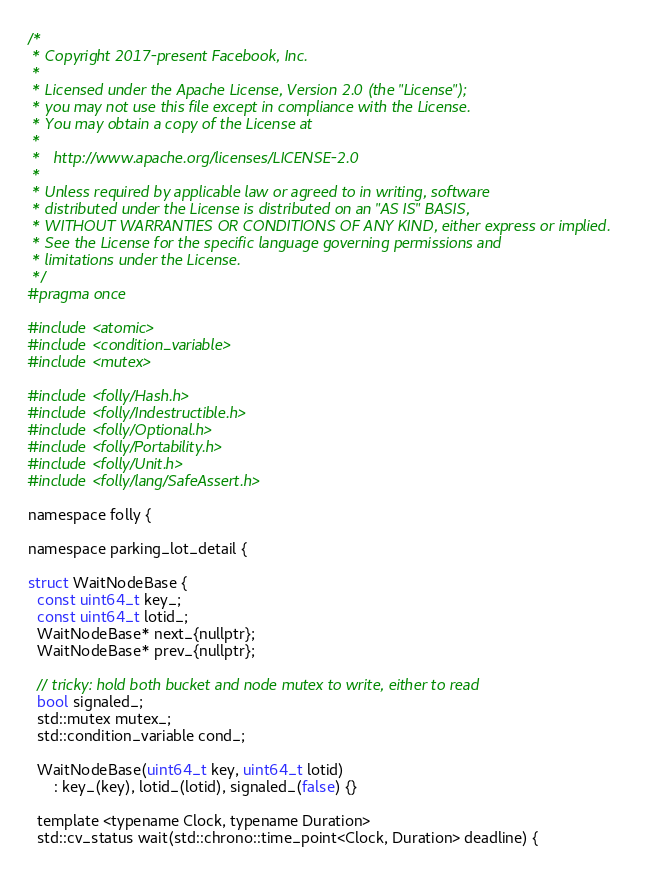<code> <loc_0><loc_0><loc_500><loc_500><_C_>/*
 * Copyright 2017-present Facebook, Inc.
 *
 * Licensed under the Apache License, Version 2.0 (the "License");
 * you may not use this file except in compliance with the License.
 * You may obtain a copy of the License at
 *
 *   http://www.apache.org/licenses/LICENSE-2.0
 *
 * Unless required by applicable law or agreed to in writing, software
 * distributed under the License is distributed on an "AS IS" BASIS,
 * WITHOUT WARRANTIES OR CONDITIONS OF ANY KIND, either express or implied.
 * See the License for the specific language governing permissions and
 * limitations under the License.
 */
#pragma once

#include <atomic>
#include <condition_variable>
#include <mutex>

#include <folly/Hash.h>
#include <folly/Indestructible.h>
#include <folly/Optional.h>
#include <folly/Portability.h>
#include <folly/Unit.h>
#include <folly/lang/SafeAssert.h>

namespace folly {

namespace parking_lot_detail {

struct WaitNodeBase {
  const uint64_t key_;
  const uint64_t lotid_;
  WaitNodeBase* next_{nullptr};
  WaitNodeBase* prev_{nullptr};

  // tricky: hold both bucket and node mutex to write, either to read
  bool signaled_;
  std::mutex mutex_;
  std::condition_variable cond_;

  WaitNodeBase(uint64_t key, uint64_t lotid)
      : key_(key), lotid_(lotid), signaled_(false) {}

  template <typename Clock, typename Duration>
  std::cv_status wait(std::chrono::time_point<Clock, Duration> deadline) {</code> 